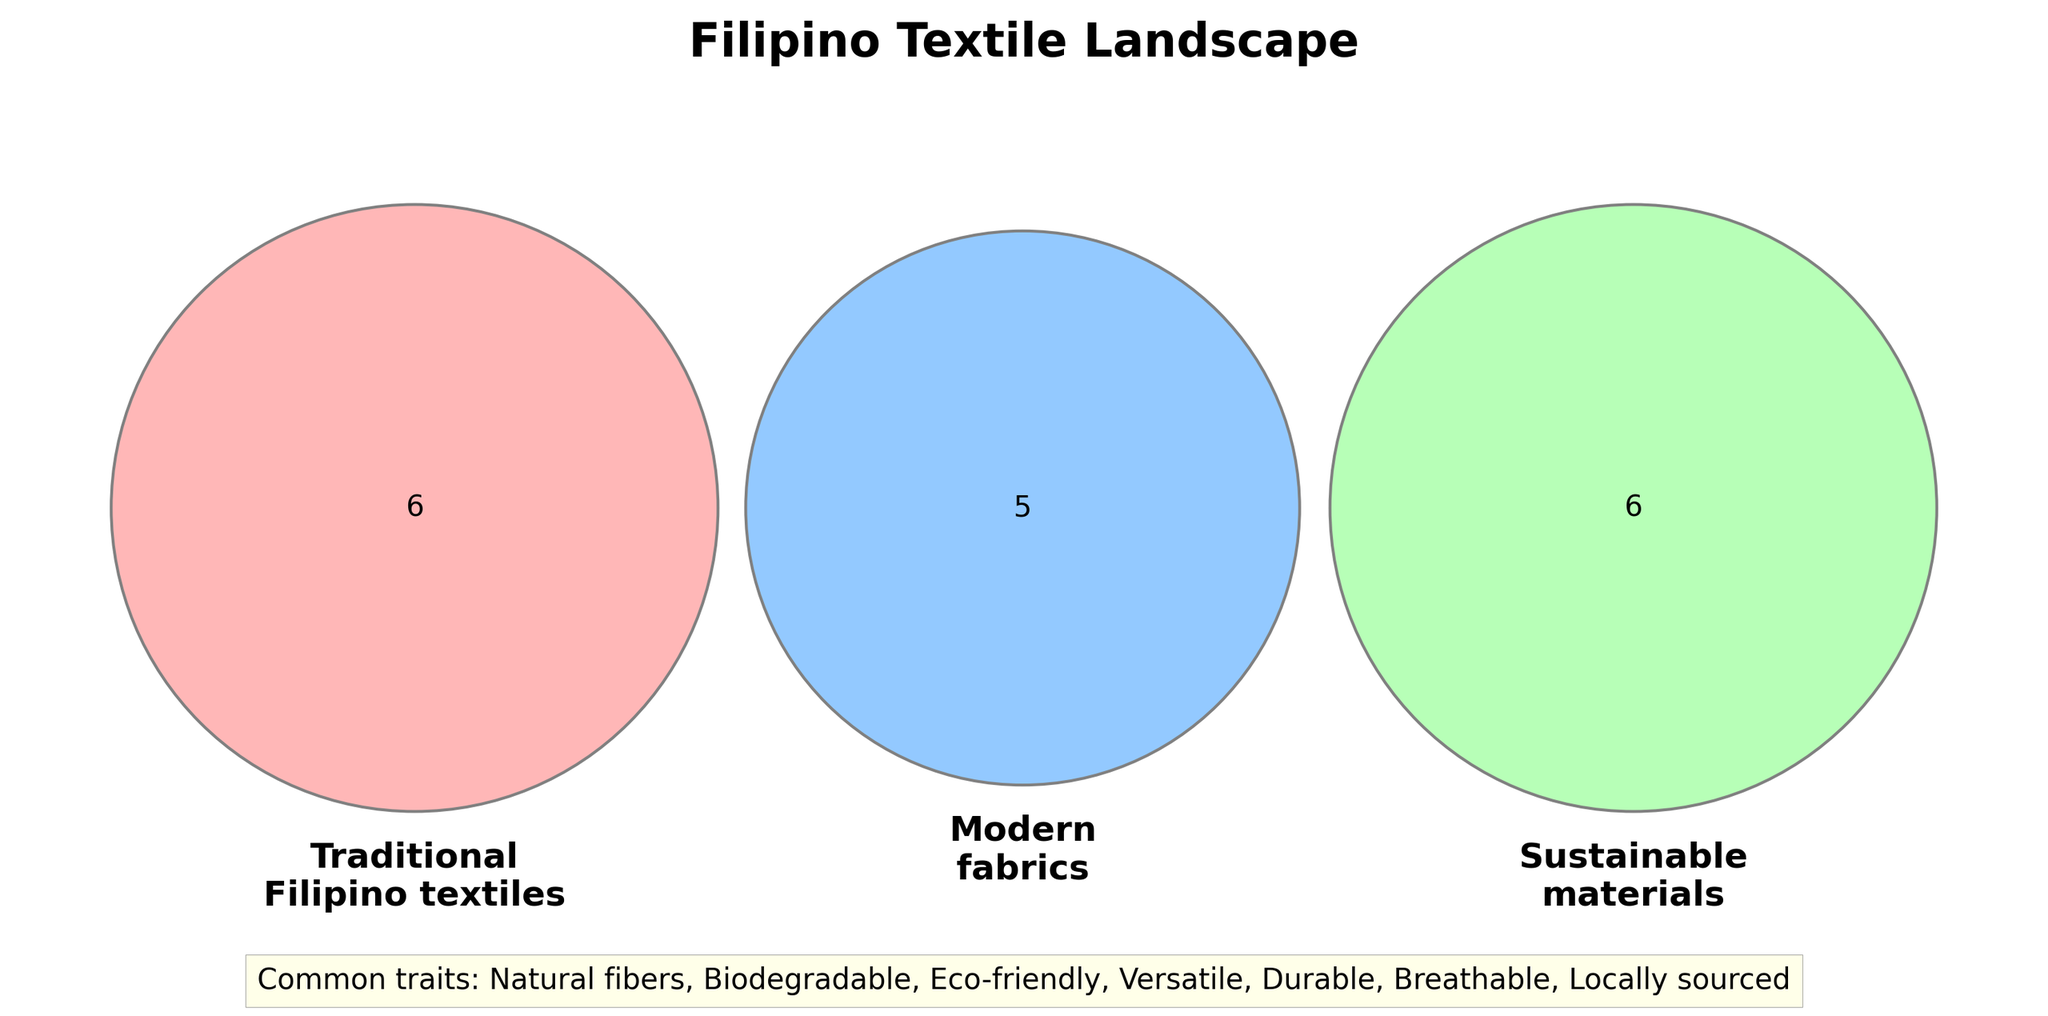What are the three main categories shown in the Venn diagram? The Venn diagram features three main categories that are Traditional Filipino textiles, Modern fabrics, and Sustainable materials. These are represented by three overlapping circles, each labeled accordingly.
Answer: Traditional Filipino textiles, Modern fabrics, Sustainable materials Which fabrics fall solely under Traditional Filipino textiles? By looking at the part of the Venn diagram where only the Traditional Filipino textiles circle is highlighted without overlapping any other circle, we can see the list of fabrics.
Answer: Piña, Abaca, Inabel, T'nalak, Hablon, Sinamay Name two fabrics that are both Modern fabrics and Sustainable materials. To find this, we look at the overlapping section between the Modern fabrics and Sustainable materials circles.
Answer: Recycled polyester, Tencel How many common traits are listed in the Venn diagram for all three categories? The common traits are listed outside the Venn diagram, under the "Common traits" note at the bottom. A quick count of these items will give us the answer.
Answer: 7 Which material is categorized under Modern fabrics but not under Traditional Filipino textiles or Sustainable materials? This requires identifying the material listed solely within the Modern fabrics section that does not overlap with the other two categories.
Answer: Polyester What common attributes do Traditional Filipino textiles and Sustainable materials share? This is found by looking at the overlap between Traditional Filipino textiles and Sustainable materials. The answer is written within the area where these two circles intersect exclusively.
Answer: Natural fibers, Biodegradable Which fabrics fall under all three categories? To answer this, we look at the intersection where all three circles overlap in the Venn diagram.
Answer: None Are there any materials that are unique to Sustainable materials? List them. We identify this by looking at the part of the Venn diagram where only the Sustainable materials circle is highlighted without overlapping any other circle.
Answer: Cork fabric Which category has the most unique materials? To solve this, we'll count the number of unique materials in each section of the Venn diagram without overlapping other sections, then compare the three counts.
Answer: Traditional Filipino textiles What is a typical characteristic shared by all categories? Look at the note under "Common traits" at the bottom of the diagram where shared characteristics are listed.
Answer: Natural fibers 